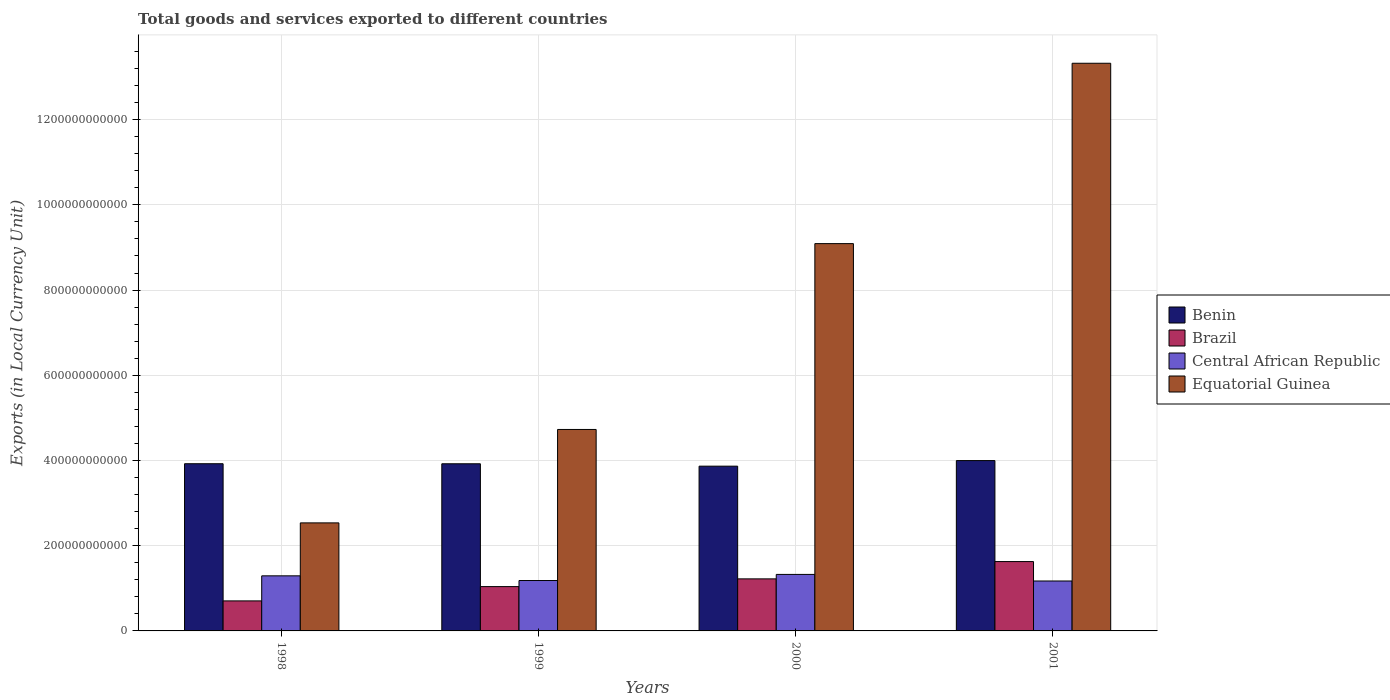How many groups of bars are there?
Make the answer very short. 4. Are the number of bars per tick equal to the number of legend labels?
Your response must be concise. Yes. Are the number of bars on each tick of the X-axis equal?
Ensure brevity in your answer.  Yes. How many bars are there on the 4th tick from the right?
Give a very brief answer. 4. What is the Amount of goods and services exports in Brazil in 2000?
Provide a succinct answer. 1.22e+11. Across all years, what is the maximum Amount of goods and services exports in Benin?
Your response must be concise. 4.00e+11. Across all years, what is the minimum Amount of goods and services exports in Central African Republic?
Offer a very short reply. 1.17e+11. In which year was the Amount of goods and services exports in Equatorial Guinea minimum?
Keep it short and to the point. 1998. What is the total Amount of goods and services exports in Equatorial Guinea in the graph?
Provide a short and direct response. 2.97e+12. What is the difference between the Amount of goods and services exports in Central African Republic in 2000 and that in 2001?
Your response must be concise. 1.54e+1. What is the difference between the Amount of goods and services exports in Benin in 1998 and the Amount of goods and services exports in Brazil in 1999?
Give a very brief answer. 2.88e+11. What is the average Amount of goods and services exports in Benin per year?
Ensure brevity in your answer.  3.93e+11. In the year 2001, what is the difference between the Amount of goods and services exports in Equatorial Guinea and Amount of goods and services exports in Central African Republic?
Your response must be concise. 1.22e+12. What is the ratio of the Amount of goods and services exports in Brazil in 1999 to that in 2000?
Your response must be concise. 0.85. What is the difference between the highest and the second highest Amount of goods and services exports in Benin?
Keep it short and to the point. 7.39e+09. What is the difference between the highest and the lowest Amount of goods and services exports in Brazil?
Make the answer very short. 9.23e+1. Is the sum of the Amount of goods and services exports in Central African Republic in 1999 and 2001 greater than the maximum Amount of goods and services exports in Brazil across all years?
Your response must be concise. Yes. Is it the case that in every year, the sum of the Amount of goods and services exports in Central African Republic and Amount of goods and services exports in Equatorial Guinea is greater than the sum of Amount of goods and services exports in Benin and Amount of goods and services exports in Brazil?
Provide a short and direct response. Yes. What does the 4th bar from the left in 2001 represents?
Provide a short and direct response. Equatorial Guinea. What does the 4th bar from the right in 2000 represents?
Offer a terse response. Benin. Is it the case that in every year, the sum of the Amount of goods and services exports in Central African Republic and Amount of goods and services exports in Brazil is greater than the Amount of goods and services exports in Benin?
Offer a very short reply. No. Are all the bars in the graph horizontal?
Ensure brevity in your answer.  No. How many years are there in the graph?
Give a very brief answer. 4. What is the difference between two consecutive major ticks on the Y-axis?
Your response must be concise. 2.00e+11. Are the values on the major ticks of Y-axis written in scientific E-notation?
Provide a short and direct response. No. Does the graph contain any zero values?
Ensure brevity in your answer.  No. Does the graph contain grids?
Offer a terse response. Yes. Where does the legend appear in the graph?
Your response must be concise. Center right. How many legend labels are there?
Your answer should be very brief. 4. How are the legend labels stacked?
Offer a very short reply. Vertical. What is the title of the graph?
Provide a short and direct response. Total goods and services exported to different countries. Does "Korea (Democratic)" appear as one of the legend labels in the graph?
Keep it short and to the point. No. What is the label or title of the Y-axis?
Offer a terse response. Exports (in Local Currency Unit). What is the Exports (in Local Currency Unit) in Benin in 1998?
Provide a succinct answer. 3.92e+11. What is the Exports (in Local Currency Unit) in Brazil in 1998?
Provide a short and direct response. 7.05e+1. What is the Exports (in Local Currency Unit) in Central African Republic in 1998?
Your answer should be very brief. 1.29e+11. What is the Exports (in Local Currency Unit) in Equatorial Guinea in 1998?
Offer a terse response. 2.54e+11. What is the Exports (in Local Currency Unit) of Benin in 1999?
Keep it short and to the point. 3.92e+11. What is the Exports (in Local Currency Unit) of Brazil in 1999?
Ensure brevity in your answer.  1.04e+11. What is the Exports (in Local Currency Unit) in Central African Republic in 1999?
Give a very brief answer. 1.18e+11. What is the Exports (in Local Currency Unit) of Equatorial Guinea in 1999?
Your answer should be compact. 4.73e+11. What is the Exports (in Local Currency Unit) in Benin in 2000?
Ensure brevity in your answer.  3.87e+11. What is the Exports (in Local Currency Unit) of Brazil in 2000?
Give a very brief answer. 1.22e+11. What is the Exports (in Local Currency Unit) of Central African Republic in 2000?
Offer a very short reply. 1.33e+11. What is the Exports (in Local Currency Unit) in Equatorial Guinea in 2000?
Offer a terse response. 9.09e+11. What is the Exports (in Local Currency Unit) in Benin in 2001?
Make the answer very short. 4.00e+11. What is the Exports (in Local Currency Unit) of Brazil in 2001?
Your answer should be compact. 1.63e+11. What is the Exports (in Local Currency Unit) in Central African Republic in 2001?
Your answer should be very brief. 1.17e+11. What is the Exports (in Local Currency Unit) of Equatorial Guinea in 2001?
Ensure brevity in your answer.  1.33e+12. Across all years, what is the maximum Exports (in Local Currency Unit) of Benin?
Provide a short and direct response. 4.00e+11. Across all years, what is the maximum Exports (in Local Currency Unit) of Brazil?
Give a very brief answer. 1.63e+11. Across all years, what is the maximum Exports (in Local Currency Unit) in Central African Republic?
Keep it short and to the point. 1.33e+11. Across all years, what is the maximum Exports (in Local Currency Unit) of Equatorial Guinea?
Your answer should be compact. 1.33e+12. Across all years, what is the minimum Exports (in Local Currency Unit) in Benin?
Offer a terse response. 3.87e+11. Across all years, what is the minimum Exports (in Local Currency Unit) in Brazil?
Your response must be concise. 7.05e+1. Across all years, what is the minimum Exports (in Local Currency Unit) in Central African Republic?
Your response must be concise. 1.17e+11. Across all years, what is the minimum Exports (in Local Currency Unit) of Equatorial Guinea?
Offer a very short reply. 2.54e+11. What is the total Exports (in Local Currency Unit) in Benin in the graph?
Your response must be concise. 1.57e+12. What is the total Exports (in Local Currency Unit) of Brazil in the graph?
Keep it short and to the point. 4.59e+11. What is the total Exports (in Local Currency Unit) of Central African Republic in the graph?
Your answer should be compact. 4.97e+11. What is the total Exports (in Local Currency Unit) of Equatorial Guinea in the graph?
Offer a terse response. 2.97e+12. What is the difference between the Exports (in Local Currency Unit) of Benin in 1998 and that in 1999?
Make the answer very short. 1.10e+08. What is the difference between the Exports (in Local Currency Unit) in Brazil in 1998 and that in 1999?
Your answer should be very brief. -3.36e+1. What is the difference between the Exports (in Local Currency Unit) of Central African Republic in 1998 and that in 1999?
Offer a very short reply. 1.10e+1. What is the difference between the Exports (in Local Currency Unit) of Equatorial Guinea in 1998 and that in 1999?
Ensure brevity in your answer.  -2.19e+11. What is the difference between the Exports (in Local Currency Unit) in Benin in 1998 and that in 2000?
Offer a terse response. 5.71e+09. What is the difference between the Exports (in Local Currency Unit) in Brazil in 1998 and that in 2000?
Offer a terse response. -5.17e+1. What is the difference between the Exports (in Local Currency Unit) in Central African Republic in 1998 and that in 2000?
Your answer should be very brief. -3.34e+09. What is the difference between the Exports (in Local Currency Unit) of Equatorial Guinea in 1998 and that in 2000?
Provide a succinct answer. -6.55e+11. What is the difference between the Exports (in Local Currency Unit) in Benin in 1998 and that in 2001?
Your response must be concise. -7.39e+09. What is the difference between the Exports (in Local Currency Unit) of Brazil in 1998 and that in 2001?
Your response must be concise. -9.23e+1. What is the difference between the Exports (in Local Currency Unit) in Central African Republic in 1998 and that in 2001?
Make the answer very short. 1.21e+1. What is the difference between the Exports (in Local Currency Unit) of Equatorial Guinea in 1998 and that in 2001?
Provide a short and direct response. -1.08e+12. What is the difference between the Exports (in Local Currency Unit) of Benin in 1999 and that in 2000?
Give a very brief answer. 5.60e+09. What is the difference between the Exports (in Local Currency Unit) in Brazil in 1999 and that in 2000?
Provide a short and direct response. -1.81e+1. What is the difference between the Exports (in Local Currency Unit) of Central African Republic in 1999 and that in 2000?
Give a very brief answer. -1.43e+1. What is the difference between the Exports (in Local Currency Unit) of Equatorial Guinea in 1999 and that in 2000?
Give a very brief answer. -4.36e+11. What is the difference between the Exports (in Local Currency Unit) in Benin in 1999 and that in 2001?
Your answer should be compact. -7.50e+09. What is the difference between the Exports (in Local Currency Unit) of Brazil in 1999 and that in 2001?
Ensure brevity in your answer.  -5.87e+1. What is the difference between the Exports (in Local Currency Unit) of Central African Republic in 1999 and that in 2001?
Offer a terse response. 1.10e+09. What is the difference between the Exports (in Local Currency Unit) in Equatorial Guinea in 1999 and that in 2001?
Make the answer very short. -8.60e+11. What is the difference between the Exports (in Local Currency Unit) in Benin in 2000 and that in 2001?
Ensure brevity in your answer.  -1.31e+1. What is the difference between the Exports (in Local Currency Unit) in Brazil in 2000 and that in 2001?
Offer a very short reply. -4.06e+1. What is the difference between the Exports (in Local Currency Unit) of Central African Republic in 2000 and that in 2001?
Provide a short and direct response. 1.54e+1. What is the difference between the Exports (in Local Currency Unit) of Equatorial Guinea in 2000 and that in 2001?
Give a very brief answer. -4.23e+11. What is the difference between the Exports (in Local Currency Unit) in Benin in 1998 and the Exports (in Local Currency Unit) in Brazil in 1999?
Ensure brevity in your answer.  2.88e+11. What is the difference between the Exports (in Local Currency Unit) in Benin in 1998 and the Exports (in Local Currency Unit) in Central African Republic in 1999?
Offer a terse response. 2.74e+11. What is the difference between the Exports (in Local Currency Unit) in Benin in 1998 and the Exports (in Local Currency Unit) in Equatorial Guinea in 1999?
Your response must be concise. -8.04e+1. What is the difference between the Exports (in Local Currency Unit) of Brazil in 1998 and the Exports (in Local Currency Unit) of Central African Republic in 1999?
Your answer should be very brief. -4.78e+1. What is the difference between the Exports (in Local Currency Unit) of Brazil in 1998 and the Exports (in Local Currency Unit) of Equatorial Guinea in 1999?
Keep it short and to the point. -4.02e+11. What is the difference between the Exports (in Local Currency Unit) in Central African Republic in 1998 and the Exports (in Local Currency Unit) in Equatorial Guinea in 1999?
Your response must be concise. -3.44e+11. What is the difference between the Exports (in Local Currency Unit) in Benin in 1998 and the Exports (in Local Currency Unit) in Brazil in 2000?
Provide a short and direct response. 2.70e+11. What is the difference between the Exports (in Local Currency Unit) in Benin in 1998 and the Exports (in Local Currency Unit) in Central African Republic in 2000?
Ensure brevity in your answer.  2.60e+11. What is the difference between the Exports (in Local Currency Unit) of Benin in 1998 and the Exports (in Local Currency Unit) of Equatorial Guinea in 2000?
Your answer should be compact. -5.17e+11. What is the difference between the Exports (in Local Currency Unit) of Brazil in 1998 and the Exports (in Local Currency Unit) of Central African Republic in 2000?
Give a very brief answer. -6.22e+1. What is the difference between the Exports (in Local Currency Unit) in Brazil in 1998 and the Exports (in Local Currency Unit) in Equatorial Guinea in 2000?
Offer a terse response. -8.39e+11. What is the difference between the Exports (in Local Currency Unit) of Central African Republic in 1998 and the Exports (in Local Currency Unit) of Equatorial Guinea in 2000?
Offer a very short reply. -7.80e+11. What is the difference between the Exports (in Local Currency Unit) in Benin in 1998 and the Exports (in Local Currency Unit) in Brazil in 2001?
Keep it short and to the point. 2.30e+11. What is the difference between the Exports (in Local Currency Unit) in Benin in 1998 and the Exports (in Local Currency Unit) in Central African Republic in 2001?
Offer a terse response. 2.75e+11. What is the difference between the Exports (in Local Currency Unit) of Benin in 1998 and the Exports (in Local Currency Unit) of Equatorial Guinea in 2001?
Keep it short and to the point. -9.40e+11. What is the difference between the Exports (in Local Currency Unit) in Brazil in 1998 and the Exports (in Local Currency Unit) in Central African Republic in 2001?
Offer a terse response. -4.67e+1. What is the difference between the Exports (in Local Currency Unit) in Brazil in 1998 and the Exports (in Local Currency Unit) in Equatorial Guinea in 2001?
Your response must be concise. -1.26e+12. What is the difference between the Exports (in Local Currency Unit) in Central African Republic in 1998 and the Exports (in Local Currency Unit) in Equatorial Guinea in 2001?
Provide a succinct answer. -1.20e+12. What is the difference between the Exports (in Local Currency Unit) of Benin in 1999 and the Exports (in Local Currency Unit) of Brazil in 2000?
Give a very brief answer. 2.70e+11. What is the difference between the Exports (in Local Currency Unit) in Benin in 1999 and the Exports (in Local Currency Unit) in Central African Republic in 2000?
Ensure brevity in your answer.  2.60e+11. What is the difference between the Exports (in Local Currency Unit) of Benin in 1999 and the Exports (in Local Currency Unit) of Equatorial Guinea in 2000?
Your answer should be very brief. -5.17e+11. What is the difference between the Exports (in Local Currency Unit) in Brazil in 1999 and the Exports (in Local Currency Unit) in Central African Republic in 2000?
Your answer should be very brief. -2.86e+1. What is the difference between the Exports (in Local Currency Unit) in Brazil in 1999 and the Exports (in Local Currency Unit) in Equatorial Guinea in 2000?
Keep it short and to the point. -8.05e+11. What is the difference between the Exports (in Local Currency Unit) of Central African Republic in 1999 and the Exports (in Local Currency Unit) of Equatorial Guinea in 2000?
Offer a terse response. -7.91e+11. What is the difference between the Exports (in Local Currency Unit) in Benin in 1999 and the Exports (in Local Currency Unit) in Brazil in 2001?
Keep it short and to the point. 2.30e+11. What is the difference between the Exports (in Local Currency Unit) in Benin in 1999 and the Exports (in Local Currency Unit) in Central African Republic in 2001?
Give a very brief answer. 2.75e+11. What is the difference between the Exports (in Local Currency Unit) in Benin in 1999 and the Exports (in Local Currency Unit) in Equatorial Guinea in 2001?
Provide a succinct answer. -9.40e+11. What is the difference between the Exports (in Local Currency Unit) in Brazil in 1999 and the Exports (in Local Currency Unit) in Central African Republic in 2001?
Your response must be concise. -1.32e+1. What is the difference between the Exports (in Local Currency Unit) of Brazil in 1999 and the Exports (in Local Currency Unit) of Equatorial Guinea in 2001?
Give a very brief answer. -1.23e+12. What is the difference between the Exports (in Local Currency Unit) in Central African Republic in 1999 and the Exports (in Local Currency Unit) in Equatorial Guinea in 2001?
Provide a succinct answer. -1.21e+12. What is the difference between the Exports (in Local Currency Unit) of Benin in 2000 and the Exports (in Local Currency Unit) of Brazil in 2001?
Your response must be concise. 2.24e+11. What is the difference between the Exports (in Local Currency Unit) of Benin in 2000 and the Exports (in Local Currency Unit) of Central African Republic in 2001?
Offer a terse response. 2.70e+11. What is the difference between the Exports (in Local Currency Unit) of Benin in 2000 and the Exports (in Local Currency Unit) of Equatorial Guinea in 2001?
Your answer should be compact. -9.46e+11. What is the difference between the Exports (in Local Currency Unit) of Brazil in 2000 and the Exports (in Local Currency Unit) of Central African Republic in 2001?
Offer a terse response. 4.97e+09. What is the difference between the Exports (in Local Currency Unit) in Brazil in 2000 and the Exports (in Local Currency Unit) in Equatorial Guinea in 2001?
Keep it short and to the point. -1.21e+12. What is the difference between the Exports (in Local Currency Unit) of Central African Republic in 2000 and the Exports (in Local Currency Unit) of Equatorial Guinea in 2001?
Ensure brevity in your answer.  -1.20e+12. What is the average Exports (in Local Currency Unit) of Benin per year?
Provide a short and direct response. 3.93e+11. What is the average Exports (in Local Currency Unit) of Brazil per year?
Offer a terse response. 1.15e+11. What is the average Exports (in Local Currency Unit) of Central African Republic per year?
Offer a very short reply. 1.24e+11. What is the average Exports (in Local Currency Unit) in Equatorial Guinea per year?
Make the answer very short. 7.42e+11. In the year 1998, what is the difference between the Exports (in Local Currency Unit) of Benin and Exports (in Local Currency Unit) of Brazil?
Offer a terse response. 3.22e+11. In the year 1998, what is the difference between the Exports (in Local Currency Unit) of Benin and Exports (in Local Currency Unit) of Central African Republic?
Offer a very short reply. 2.63e+11. In the year 1998, what is the difference between the Exports (in Local Currency Unit) in Benin and Exports (in Local Currency Unit) in Equatorial Guinea?
Your response must be concise. 1.39e+11. In the year 1998, what is the difference between the Exports (in Local Currency Unit) of Brazil and Exports (in Local Currency Unit) of Central African Republic?
Provide a succinct answer. -5.88e+1. In the year 1998, what is the difference between the Exports (in Local Currency Unit) in Brazil and Exports (in Local Currency Unit) in Equatorial Guinea?
Provide a short and direct response. -1.83e+11. In the year 1998, what is the difference between the Exports (in Local Currency Unit) of Central African Republic and Exports (in Local Currency Unit) of Equatorial Guinea?
Offer a very short reply. -1.24e+11. In the year 1999, what is the difference between the Exports (in Local Currency Unit) in Benin and Exports (in Local Currency Unit) in Brazil?
Offer a terse response. 2.88e+11. In the year 1999, what is the difference between the Exports (in Local Currency Unit) of Benin and Exports (in Local Currency Unit) of Central African Republic?
Ensure brevity in your answer.  2.74e+11. In the year 1999, what is the difference between the Exports (in Local Currency Unit) in Benin and Exports (in Local Currency Unit) in Equatorial Guinea?
Your response must be concise. -8.05e+1. In the year 1999, what is the difference between the Exports (in Local Currency Unit) in Brazil and Exports (in Local Currency Unit) in Central African Republic?
Provide a succinct answer. -1.43e+1. In the year 1999, what is the difference between the Exports (in Local Currency Unit) in Brazil and Exports (in Local Currency Unit) in Equatorial Guinea?
Provide a short and direct response. -3.69e+11. In the year 1999, what is the difference between the Exports (in Local Currency Unit) in Central African Republic and Exports (in Local Currency Unit) in Equatorial Guinea?
Provide a succinct answer. -3.55e+11. In the year 2000, what is the difference between the Exports (in Local Currency Unit) in Benin and Exports (in Local Currency Unit) in Brazil?
Offer a terse response. 2.65e+11. In the year 2000, what is the difference between the Exports (in Local Currency Unit) of Benin and Exports (in Local Currency Unit) of Central African Republic?
Your response must be concise. 2.54e+11. In the year 2000, what is the difference between the Exports (in Local Currency Unit) of Benin and Exports (in Local Currency Unit) of Equatorial Guinea?
Your answer should be very brief. -5.22e+11. In the year 2000, what is the difference between the Exports (in Local Currency Unit) in Brazil and Exports (in Local Currency Unit) in Central African Republic?
Your response must be concise. -1.05e+1. In the year 2000, what is the difference between the Exports (in Local Currency Unit) in Brazil and Exports (in Local Currency Unit) in Equatorial Guinea?
Your answer should be very brief. -7.87e+11. In the year 2000, what is the difference between the Exports (in Local Currency Unit) of Central African Republic and Exports (in Local Currency Unit) of Equatorial Guinea?
Provide a short and direct response. -7.76e+11. In the year 2001, what is the difference between the Exports (in Local Currency Unit) of Benin and Exports (in Local Currency Unit) of Brazil?
Your answer should be compact. 2.37e+11. In the year 2001, what is the difference between the Exports (in Local Currency Unit) of Benin and Exports (in Local Currency Unit) of Central African Republic?
Give a very brief answer. 2.83e+11. In the year 2001, what is the difference between the Exports (in Local Currency Unit) of Benin and Exports (in Local Currency Unit) of Equatorial Guinea?
Provide a succinct answer. -9.33e+11. In the year 2001, what is the difference between the Exports (in Local Currency Unit) in Brazil and Exports (in Local Currency Unit) in Central African Republic?
Make the answer very short. 4.56e+1. In the year 2001, what is the difference between the Exports (in Local Currency Unit) of Brazil and Exports (in Local Currency Unit) of Equatorial Guinea?
Ensure brevity in your answer.  -1.17e+12. In the year 2001, what is the difference between the Exports (in Local Currency Unit) of Central African Republic and Exports (in Local Currency Unit) of Equatorial Guinea?
Provide a succinct answer. -1.22e+12. What is the ratio of the Exports (in Local Currency Unit) in Brazil in 1998 to that in 1999?
Your answer should be compact. 0.68. What is the ratio of the Exports (in Local Currency Unit) of Central African Republic in 1998 to that in 1999?
Your answer should be very brief. 1.09. What is the ratio of the Exports (in Local Currency Unit) of Equatorial Guinea in 1998 to that in 1999?
Make the answer very short. 0.54. What is the ratio of the Exports (in Local Currency Unit) of Benin in 1998 to that in 2000?
Give a very brief answer. 1.01. What is the ratio of the Exports (in Local Currency Unit) in Brazil in 1998 to that in 2000?
Give a very brief answer. 0.58. What is the ratio of the Exports (in Local Currency Unit) in Central African Republic in 1998 to that in 2000?
Offer a terse response. 0.97. What is the ratio of the Exports (in Local Currency Unit) of Equatorial Guinea in 1998 to that in 2000?
Provide a short and direct response. 0.28. What is the ratio of the Exports (in Local Currency Unit) in Benin in 1998 to that in 2001?
Offer a very short reply. 0.98. What is the ratio of the Exports (in Local Currency Unit) in Brazil in 1998 to that in 2001?
Your answer should be compact. 0.43. What is the ratio of the Exports (in Local Currency Unit) in Central African Republic in 1998 to that in 2001?
Offer a very short reply. 1.1. What is the ratio of the Exports (in Local Currency Unit) in Equatorial Guinea in 1998 to that in 2001?
Give a very brief answer. 0.19. What is the ratio of the Exports (in Local Currency Unit) in Benin in 1999 to that in 2000?
Keep it short and to the point. 1.01. What is the ratio of the Exports (in Local Currency Unit) of Brazil in 1999 to that in 2000?
Keep it short and to the point. 0.85. What is the ratio of the Exports (in Local Currency Unit) of Central African Republic in 1999 to that in 2000?
Provide a short and direct response. 0.89. What is the ratio of the Exports (in Local Currency Unit) of Equatorial Guinea in 1999 to that in 2000?
Provide a succinct answer. 0.52. What is the ratio of the Exports (in Local Currency Unit) in Benin in 1999 to that in 2001?
Your answer should be compact. 0.98. What is the ratio of the Exports (in Local Currency Unit) in Brazil in 1999 to that in 2001?
Your response must be concise. 0.64. What is the ratio of the Exports (in Local Currency Unit) in Central African Republic in 1999 to that in 2001?
Make the answer very short. 1.01. What is the ratio of the Exports (in Local Currency Unit) of Equatorial Guinea in 1999 to that in 2001?
Provide a succinct answer. 0.35. What is the ratio of the Exports (in Local Currency Unit) of Benin in 2000 to that in 2001?
Provide a short and direct response. 0.97. What is the ratio of the Exports (in Local Currency Unit) in Brazil in 2000 to that in 2001?
Make the answer very short. 0.75. What is the ratio of the Exports (in Local Currency Unit) in Central African Republic in 2000 to that in 2001?
Make the answer very short. 1.13. What is the ratio of the Exports (in Local Currency Unit) of Equatorial Guinea in 2000 to that in 2001?
Keep it short and to the point. 0.68. What is the difference between the highest and the second highest Exports (in Local Currency Unit) in Benin?
Make the answer very short. 7.39e+09. What is the difference between the highest and the second highest Exports (in Local Currency Unit) in Brazil?
Give a very brief answer. 4.06e+1. What is the difference between the highest and the second highest Exports (in Local Currency Unit) of Central African Republic?
Your response must be concise. 3.34e+09. What is the difference between the highest and the second highest Exports (in Local Currency Unit) of Equatorial Guinea?
Keep it short and to the point. 4.23e+11. What is the difference between the highest and the lowest Exports (in Local Currency Unit) of Benin?
Keep it short and to the point. 1.31e+1. What is the difference between the highest and the lowest Exports (in Local Currency Unit) in Brazil?
Keep it short and to the point. 9.23e+1. What is the difference between the highest and the lowest Exports (in Local Currency Unit) of Central African Republic?
Provide a short and direct response. 1.54e+1. What is the difference between the highest and the lowest Exports (in Local Currency Unit) in Equatorial Guinea?
Provide a short and direct response. 1.08e+12. 